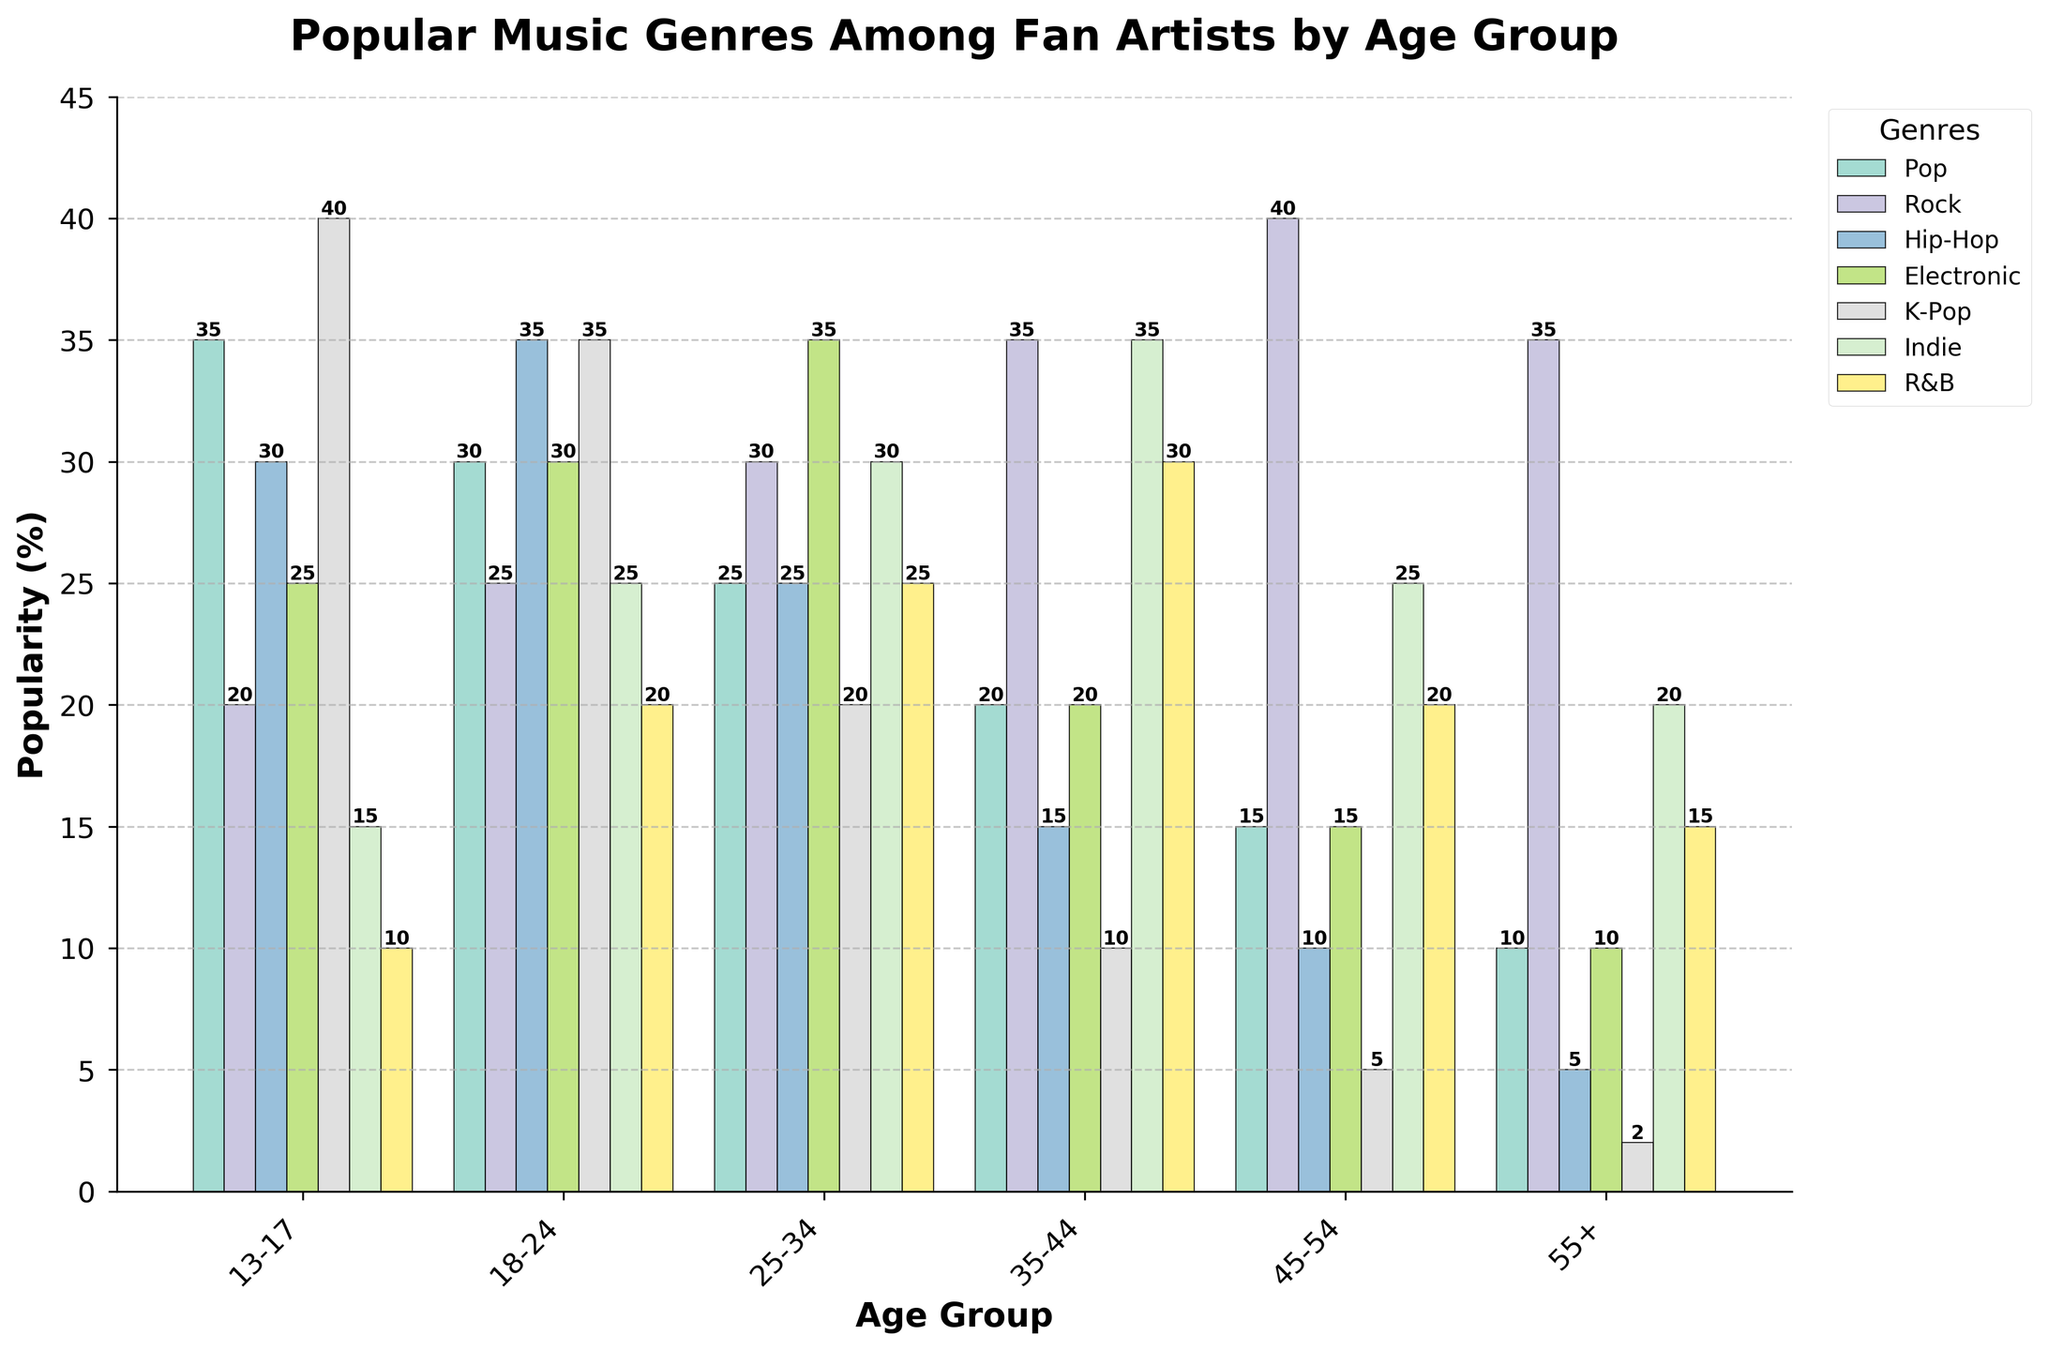Which age group prefers Indie music the most? By looking at the height of the bars, we can see that the 35-44 age group has the tallest bar for Indie music at 35%.
Answer: 35-44 Which two age groups have the closest popularity percentages for Pop music? By comparing the heights of the bars for Pop music, the 18-24 and 25-34 age groups have percentages of 30% and 25%, respectively, which are the closest.
Answer: 18-24 and 25-34 What is the difference in popularity of Hip-Hop between the 13-17 and 45-54 age groups? The percentage for Hip-Hop in the 13-17 age group is 30%, and for the 45-54 age group, it is 10%. The difference is 30% - 10% = 20%.
Answer: 20% Which genre is the least popular among the 55+ age group? By looking at the height of the bars for the 55+ age group, we see that the smallest bar is for Hip-Hop with 5%.
Answer: Hip-Hop How does the popularity of R&B in the 25-34 age group compare to the 35-44 age group? For the 25-34 age group, R&B is at 25%, whereas for the 35-44 age group, it is at 30%. Therefore, R&B is more popular in the 35-44 age group.
Answer: 35-44 Which genre has the most consistent popularity across all age groups? By looking at the bars for each genre across all age groups, Rock shows relatively less variation in bar heights, making it the most consistent.
Answer: Rock Calculate the average popularity of K-Pop across all age groups. The K-Pop percentages across age groups are 40%, 35%, 20%, 10%, 5%, and 2%. Sum them up (40 + 35 + 20 + 10 + 5 + 2) = 112, then divide by 6 age groups, 112/6 ≈ 18.67%.
Answer: 18.67% Which age group has the highest total popularity percentage when combining the genres Pop and Rock? The percentages for Pop and Rock by age group are summed as follows: 
13-17: 35 + 20 = 55,
18-24: 30 + 25 = 55,
25-34: 25 + 30 = 55,
35-44: 20 + 35 = 55,
45-54: 15 + 40 = 55,
55+: 10 + 35 = 45.
All age groups except for 55+ have the same highest total of 55%.
Answer: 13-17, 18-24, 25-34, 35-44, and 45-54 What is the combined popularity percentage of Electronic and Indie music for the 25-34 age group? The percentages for Electronic and Indie in the 25-34 age group are 35% and 30%, respectively. Summing these, 35% + 30% = 65%.
Answer: 65% 